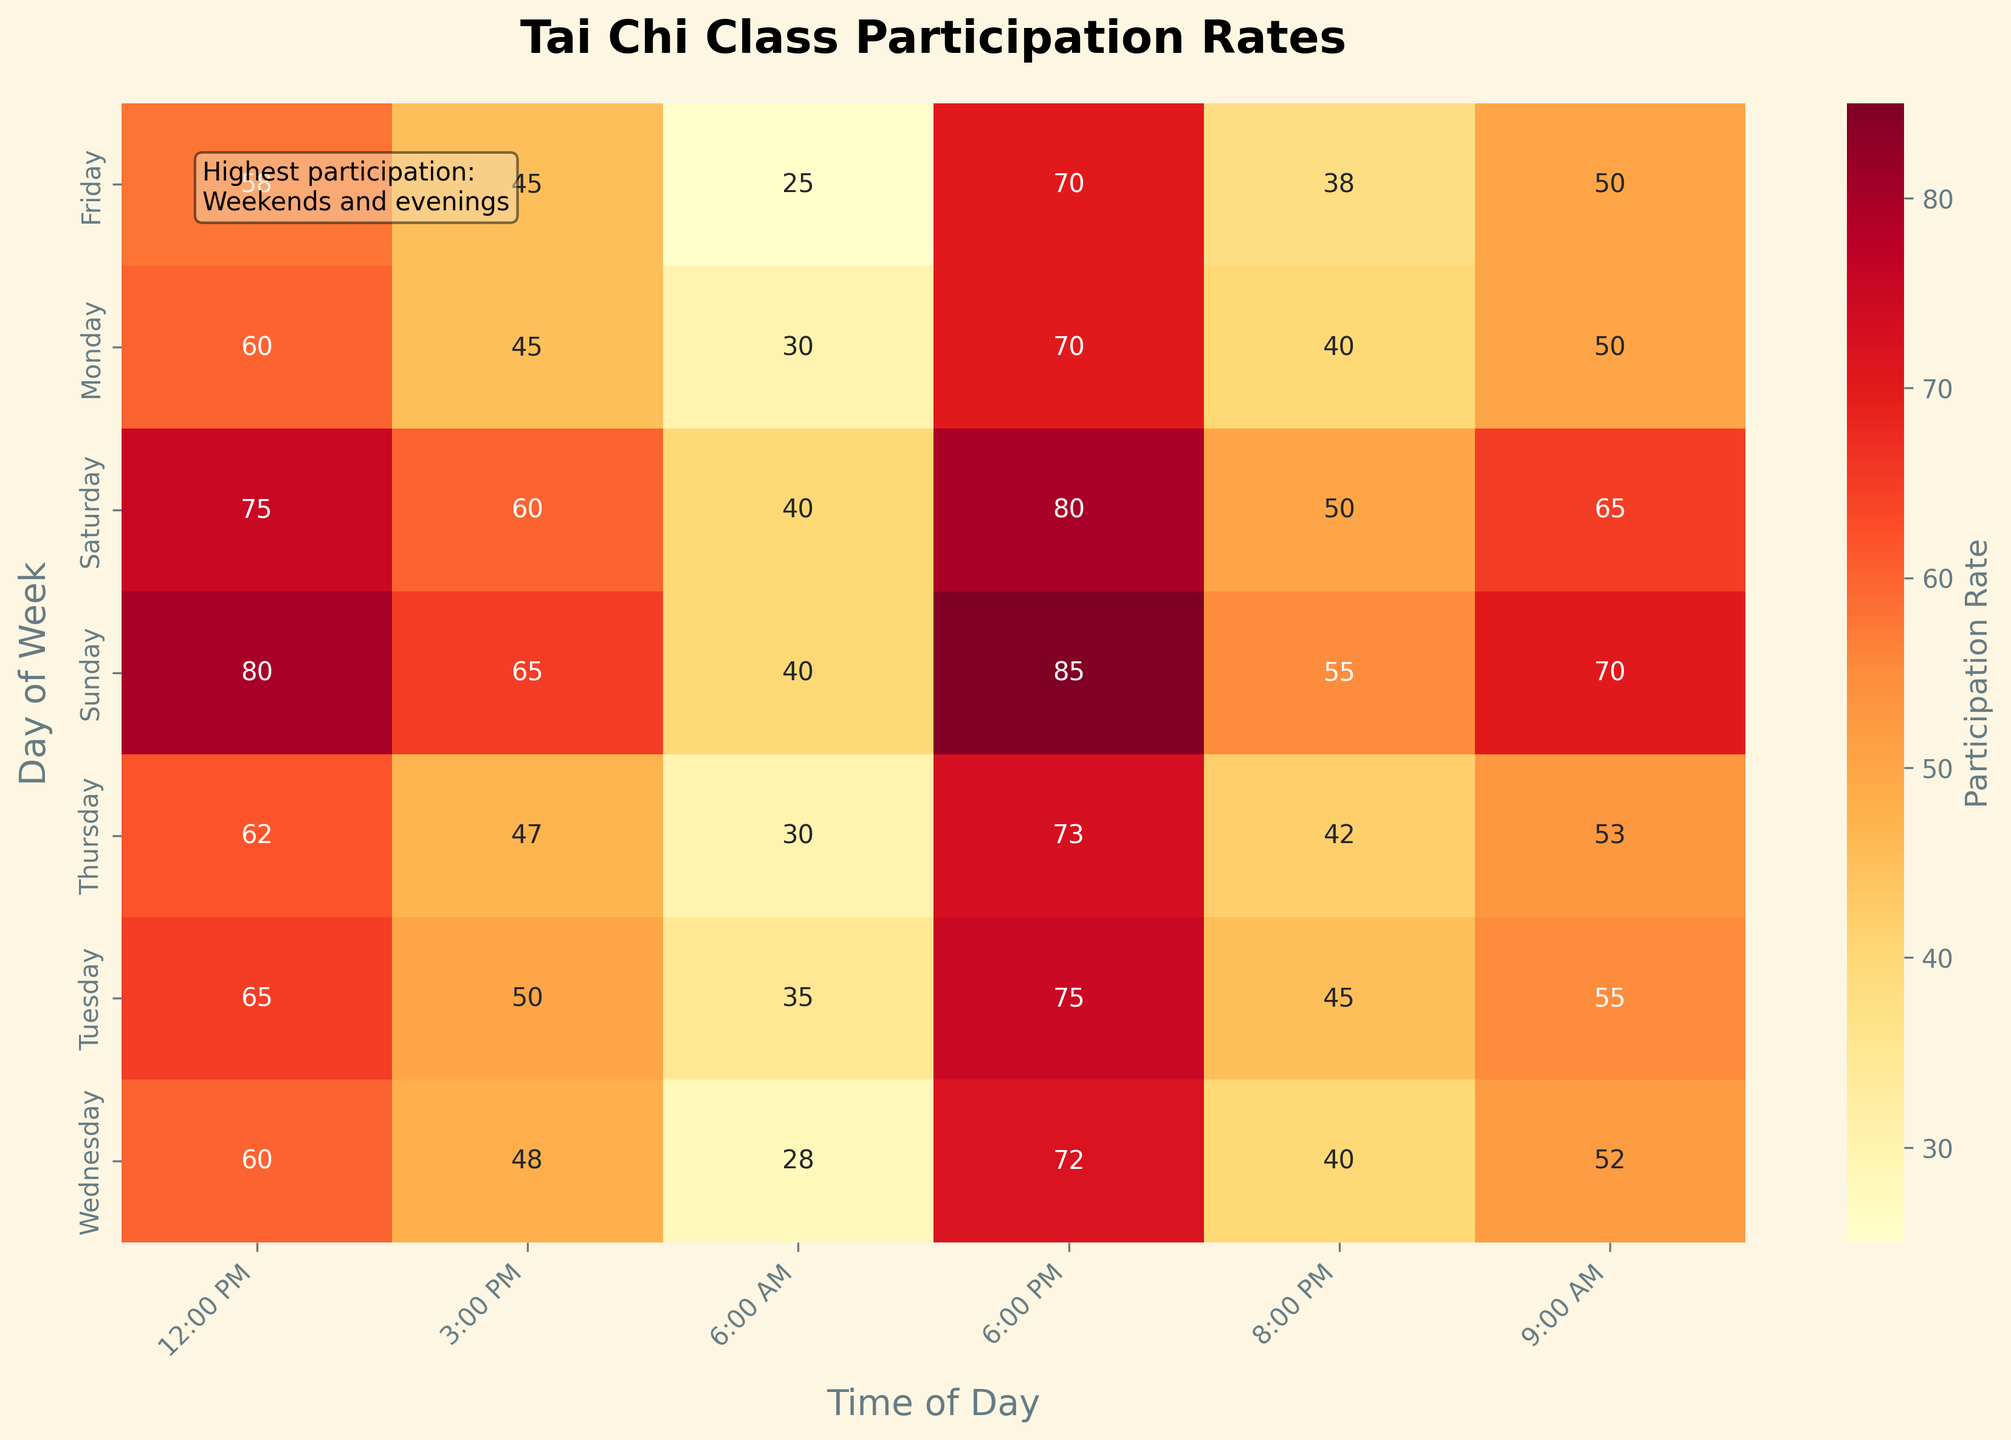What day has the highest participation rate at 6:00 PM? Look at the column for 6:00 PM and find the highest value, which is 85 on Sunday.
Answer: Sunday Which time slot generally has the lowest participation rates throughout the week? Compare each time slot across all days and identify which one has the consistently lowest values. The 6:00 AM slot tends to have the lowest participation rates.
Answer: 6:00 AM How does the participation rate on Monday at 12:00 PM compare to Wednesday at the same time? Check the values for Monday at 12:00 PM and Wednesday at 12:00 PM. Both are 60, so they are equal.
Answer: They are equal Which day has the greatest variation in participation rates? Look at the range of participation rates for each day by finding the difference between the highest and lowest values. For Sunday, the range is 85 - 40 = 45, which is the largest.
Answer: Sunday What is the average participation rate for the 9:00 AM time slot across the week? Add up the values for the 9:00 AM slot for all days (50 + 55 + 52 + 53 + 50 + 65 + 70 = 395) and divide by the number of days (7). So, 395 / 7 ≈ 56.4.
Answer: 56.4 Is the participation rate higher on average during weekdays or weekends at 8:00 PM? Average the values for 8:00 PM on Monday through Friday (40 + 45 + 40 + 42 + 38 = 205, then 205 / 5 = 41). For Saturday and Sunday, average is (50 + 55 = 105, then 105 / 2 = 52.5).
Answer: Weekends What is the overall trend in participation rates from morning to evening on Sunday? Observe the increase in participation rates from 40 at 6:00 AM to a peak of 85 at 6:00 PM and then a decrease to 55 at 8:00 PM. The trend is mostly increasing throughout the day with a slight decrease at the end.
Answer: Increasing Are there any days where participation rates are consistently high across all time slots? Examine each day's values to see if they remain relatively high. Sunday has high participation rates throughout the day (40 to 85).
Answer: Yes, Sunday Which time slot has the highest participation rate of all, and what is that rate? Look through all the values in the heatmap and identify the highest single value which is 85 at 6:00 PM on Sunday.
Answer: 6:00 PM, 85 What is the difference in participation rates between 12:00 PM and 3:00 PM on Saturday? Subtract the value at 3:00 PM (60) from the value at 12:00 PM (75), which gives 75 - 60 = 15.
Answer: 15 